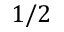<formula> <loc_0><loc_0><loc_500><loc_500>1 / 2</formula> 